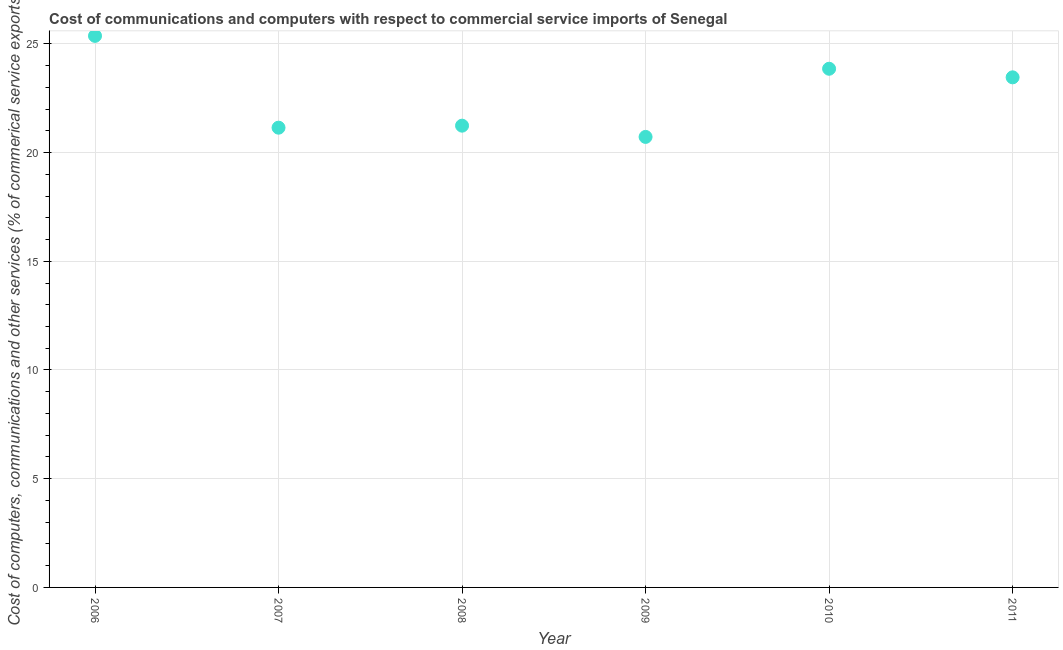What is the  computer and other services in 2006?
Your answer should be very brief. 25.37. Across all years, what is the maximum cost of communications?
Offer a very short reply. 25.37. Across all years, what is the minimum cost of communications?
Offer a very short reply. 20.72. In which year was the  computer and other services minimum?
Offer a very short reply. 2009. What is the sum of the  computer and other services?
Give a very brief answer. 135.78. What is the difference between the  computer and other services in 2006 and 2010?
Make the answer very short. 1.51. What is the average  computer and other services per year?
Provide a short and direct response. 22.63. What is the median  computer and other services?
Offer a very short reply. 22.35. Do a majority of the years between 2007 and 2010 (inclusive) have cost of communications greater than 23 %?
Your answer should be very brief. No. What is the ratio of the cost of communications in 2008 to that in 2010?
Make the answer very short. 0.89. Is the  computer and other services in 2009 less than that in 2010?
Provide a short and direct response. Yes. Is the difference between the cost of communications in 2006 and 2010 greater than the difference between any two years?
Provide a short and direct response. No. What is the difference between the highest and the second highest  computer and other services?
Your answer should be compact. 1.51. Is the sum of the cost of communications in 2008 and 2011 greater than the maximum cost of communications across all years?
Provide a short and direct response. Yes. What is the difference between the highest and the lowest  computer and other services?
Offer a terse response. 4.65. Does the  computer and other services monotonically increase over the years?
Give a very brief answer. No. How many dotlines are there?
Make the answer very short. 1. What is the difference between two consecutive major ticks on the Y-axis?
Provide a short and direct response. 5. Are the values on the major ticks of Y-axis written in scientific E-notation?
Ensure brevity in your answer.  No. Does the graph contain any zero values?
Make the answer very short. No. What is the title of the graph?
Your answer should be compact. Cost of communications and computers with respect to commercial service imports of Senegal. What is the label or title of the X-axis?
Give a very brief answer. Year. What is the label or title of the Y-axis?
Give a very brief answer. Cost of computers, communications and other services (% of commerical service exports). What is the Cost of computers, communications and other services (% of commerical service exports) in 2006?
Offer a terse response. 25.37. What is the Cost of computers, communications and other services (% of commerical service exports) in 2007?
Your answer should be compact. 21.14. What is the Cost of computers, communications and other services (% of commerical service exports) in 2008?
Provide a succinct answer. 21.24. What is the Cost of computers, communications and other services (% of commerical service exports) in 2009?
Your answer should be compact. 20.72. What is the Cost of computers, communications and other services (% of commerical service exports) in 2010?
Your answer should be compact. 23.85. What is the Cost of computers, communications and other services (% of commerical service exports) in 2011?
Offer a terse response. 23.46. What is the difference between the Cost of computers, communications and other services (% of commerical service exports) in 2006 and 2007?
Offer a terse response. 4.22. What is the difference between the Cost of computers, communications and other services (% of commerical service exports) in 2006 and 2008?
Your answer should be very brief. 4.13. What is the difference between the Cost of computers, communications and other services (% of commerical service exports) in 2006 and 2009?
Provide a succinct answer. 4.65. What is the difference between the Cost of computers, communications and other services (% of commerical service exports) in 2006 and 2010?
Give a very brief answer. 1.51. What is the difference between the Cost of computers, communications and other services (% of commerical service exports) in 2006 and 2011?
Provide a short and direct response. 1.91. What is the difference between the Cost of computers, communications and other services (% of commerical service exports) in 2007 and 2008?
Offer a terse response. -0.09. What is the difference between the Cost of computers, communications and other services (% of commerical service exports) in 2007 and 2009?
Make the answer very short. 0.42. What is the difference between the Cost of computers, communications and other services (% of commerical service exports) in 2007 and 2010?
Your answer should be very brief. -2.71. What is the difference between the Cost of computers, communications and other services (% of commerical service exports) in 2007 and 2011?
Give a very brief answer. -2.32. What is the difference between the Cost of computers, communications and other services (% of commerical service exports) in 2008 and 2009?
Your answer should be very brief. 0.52. What is the difference between the Cost of computers, communications and other services (% of commerical service exports) in 2008 and 2010?
Make the answer very short. -2.62. What is the difference between the Cost of computers, communications and other services (% of commerical service exports) in 2008 and 2011?
Ensure brevity in your answer.  -2.22. What is the difference between the Cost of computers, communications and other services (% of commerical service exports) in 2009 and 2010?
Give a very brief answer. -3.13. What is the difference between the Cost of computers, communications and other services (% of commerical service exports) in 2009 and 2011?
Your answer should be compact. -2.74. What is the difference between the Cost of computers, communications and other services (% of commerical service exports) in 2010 and 2011?
Ensure brevity in your answer.  0.39. What is the ratio of the Cost of computers, communications and other services (% of commerical service exports) in 2006 to that in 2008?
Give a very brief answer. 1.19. What is the ratio of the Cost of computers, communications and other services (% of commerical service exports) in 2006 to that in 2009?
Keep it short and to the point. 1.22. What is the ratio of the Cost of computers, communications and other services (% of commerical service exports) in 2006 to that in 2010?
Make the answer very short. 1.06. What is the ratio of the Cost of computers, communications and other services (% of commerical service exports) in 2006 to that in 2011?
Offer a very short reply. 1.08. What is the ratio of the Cost of computers, communications and other services (% of commerical service exports) in 2007 to that in 2009?
Keep it short and to the point. 1.02. What is the ratio of the Cost of computers, communications and other services (% of commerical service exports) in 2007 to that in 2010?
Provide a succinct answer. 0.89. What is the ratio of the Cost of computers, communications and other services (% of commerical service exports) in 2007 to that in 2011?
Provide a short and direct response. 0.9. What is the ratio of the Cost of computers, communications and other services (% of commerical service exports) in 2008 to that in 2009?
Provide a succinct answer. 1.02. What is the ratio of the Cost of computers, communications and other services (% of commerical service exports) in 2008 to that in 2010?
Provide a short and direct response. 0.89. What is the ratio of the Cost of computers, communications and other services (% of commerical service exports) in 2008 to that in 2011?
Offer a very short reply. 0.91. What is the ratio of the Cost of computers, communications and other services (% of commerical service exports) in 2009 to that in 2010?
Your answer should be very brief. 0.87. What is the ratio of the Cost of computers, communications and other services (% of commerical service exports) in 2009 to that in 2011?
Offer a very short reply. 0.88. 